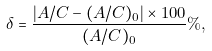Convert formula to latex. <formula><loc_0><loc_0><loc_500><loc_500>\delta = \frac { \left | A / C - ( A / C ) _ { 0 } \right | \times 1 0 0 } { ( A / C ) _ { 0 } } \% ,</formula> 